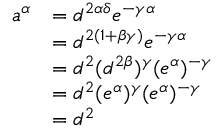<formula> <loc_0><loc_0><loc_500><loc_500>\begin{array} { r l } { a ^ { \alpha } } & { = d ^ { 2 \alpha \delta } e ^ { - \gamma \alpha } } \\ & { = d ^ { 2 ( 1 + \beta \gamma ) } e ^ { - \gamma \alpha } } \\ & { = d ^ { 2 } ( d ^ { 2 \beta } ) ^ { \gamma } ( e ^ { \alpha } ) ^ { - \gamma } } \\ & { = d ^ { 2 } ( e ^ { \alpha } ) ^ { \gamma } ( e ^ { \alpha } ) ^ { - \gamma } } \\ & { = d ^ { 2 } } \end{array}</formula> 